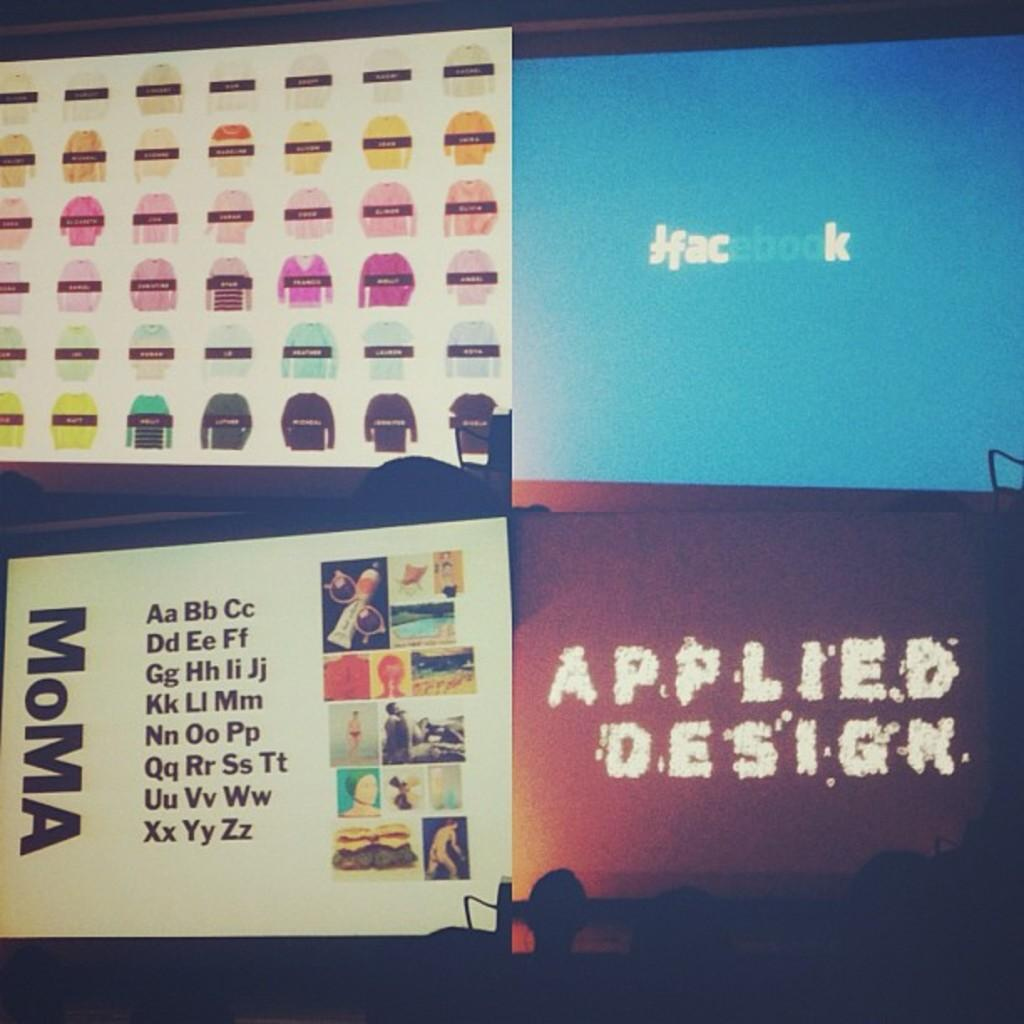What objects are present in the image? There are boards in the image. What is depicted on the boards? The boards have images and logos on them. Can you tell me who gave their approval for the cakes in the image? There are no cakes present in the image, so it is not possible to determine who gave their approval for them. 